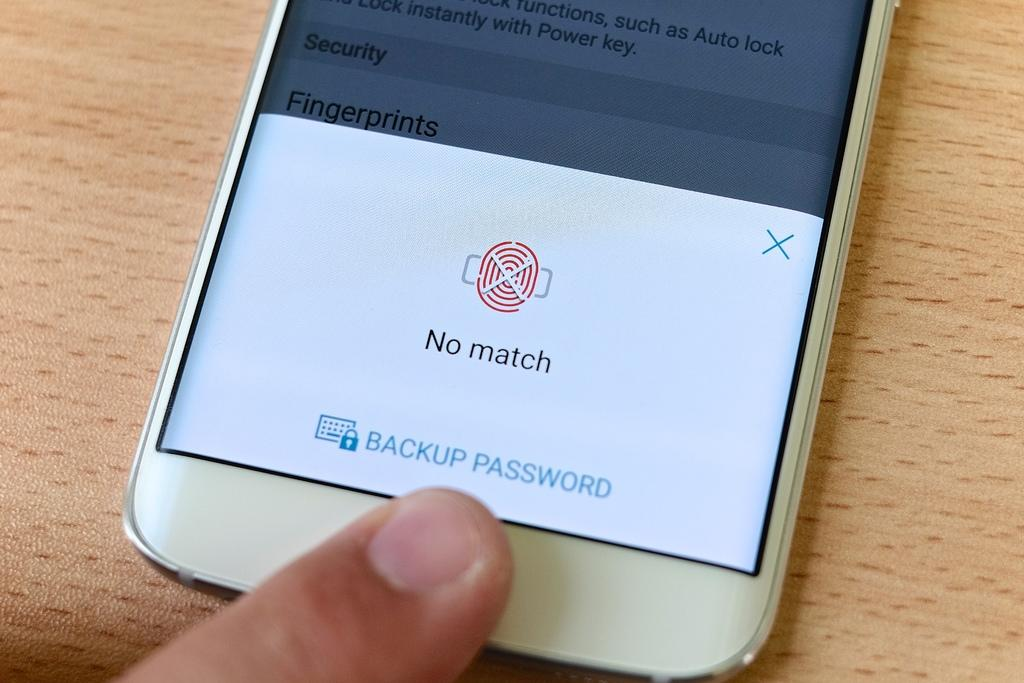<image>
Write a terse but informative summary of the picture. A cell phone user can't log in because his fingerprint shows no match. 